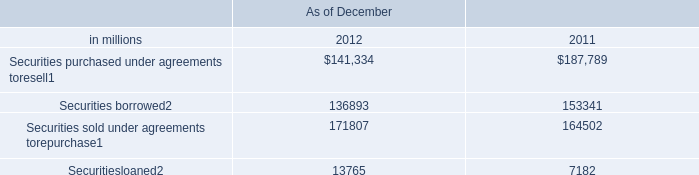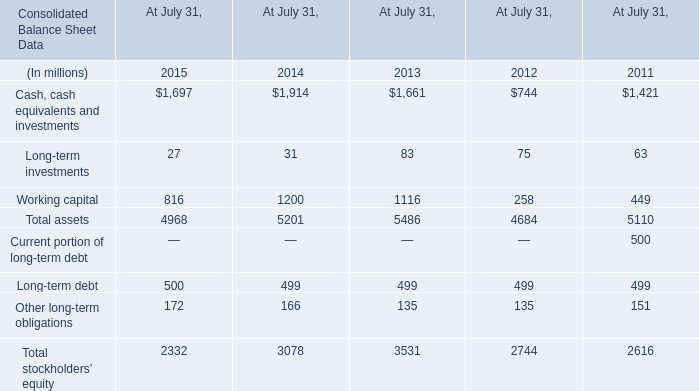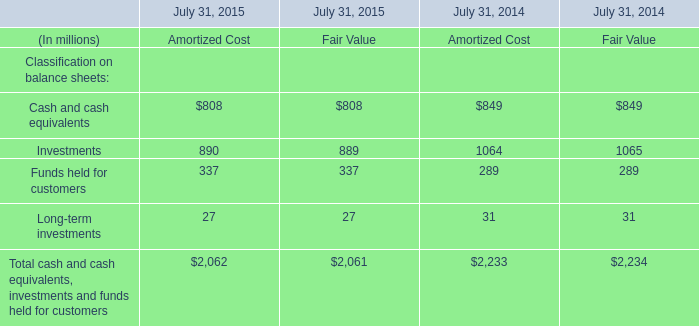What is the sum of Cash, cash equivalents and investments of At July 31, 2013, and Securities sold under agreements torepurchase of As of December 2012 ? 
Computations: (1661.0 + 171807.0)
Answer: 173468.0. 